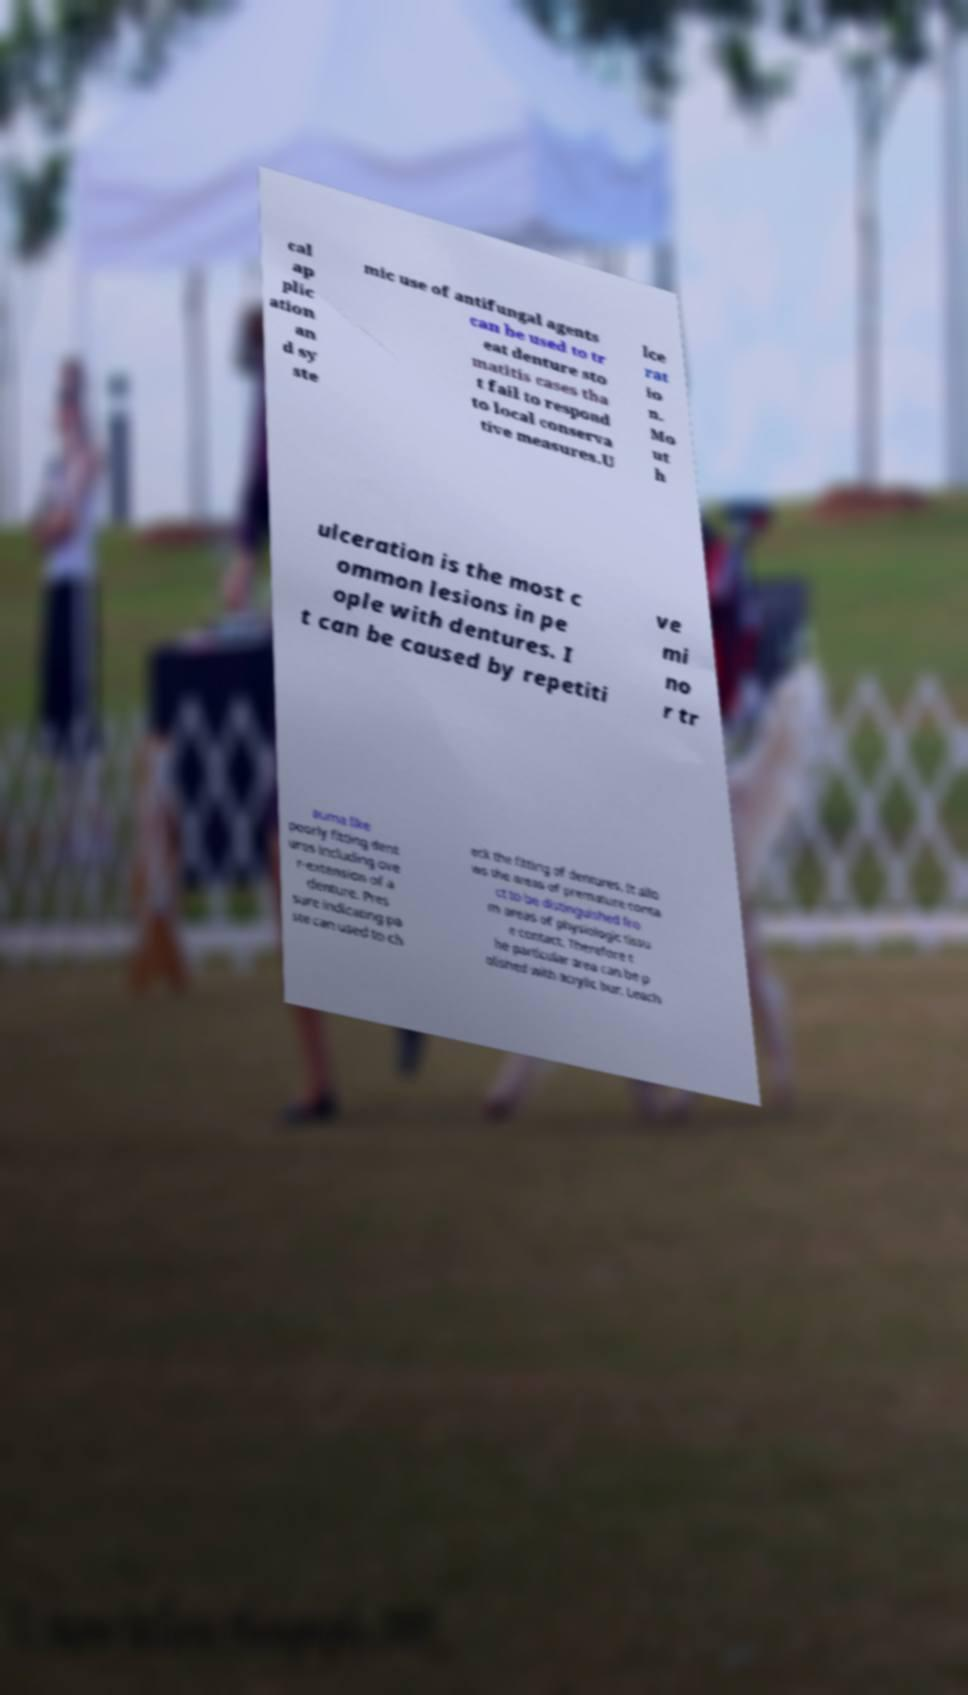For documentation purposes, I need the text within this image transcribed. Could you provide that? cal ap plic ation an d sy ste mic use of antifungal agents can be used to tr eat denture sto matitis cases tha t fail to respond to local conserva tive measures.U lce rat io n. Mo ut h ulceration is the most c ommon lesions in pe ople with dentures. I t can be caused by repetiti ve mi no r tr auma like poorly fitting dent ures including ove r-extension of a denture. Pres sure indicating pa ste can used to ch eck the fitting of dentures. It allo ws the areas of premature conta ct to be distinguished fro m areas of physiologic tissu e contact. Therefore t he particular area can be p olished with acrylic bur. Leach 